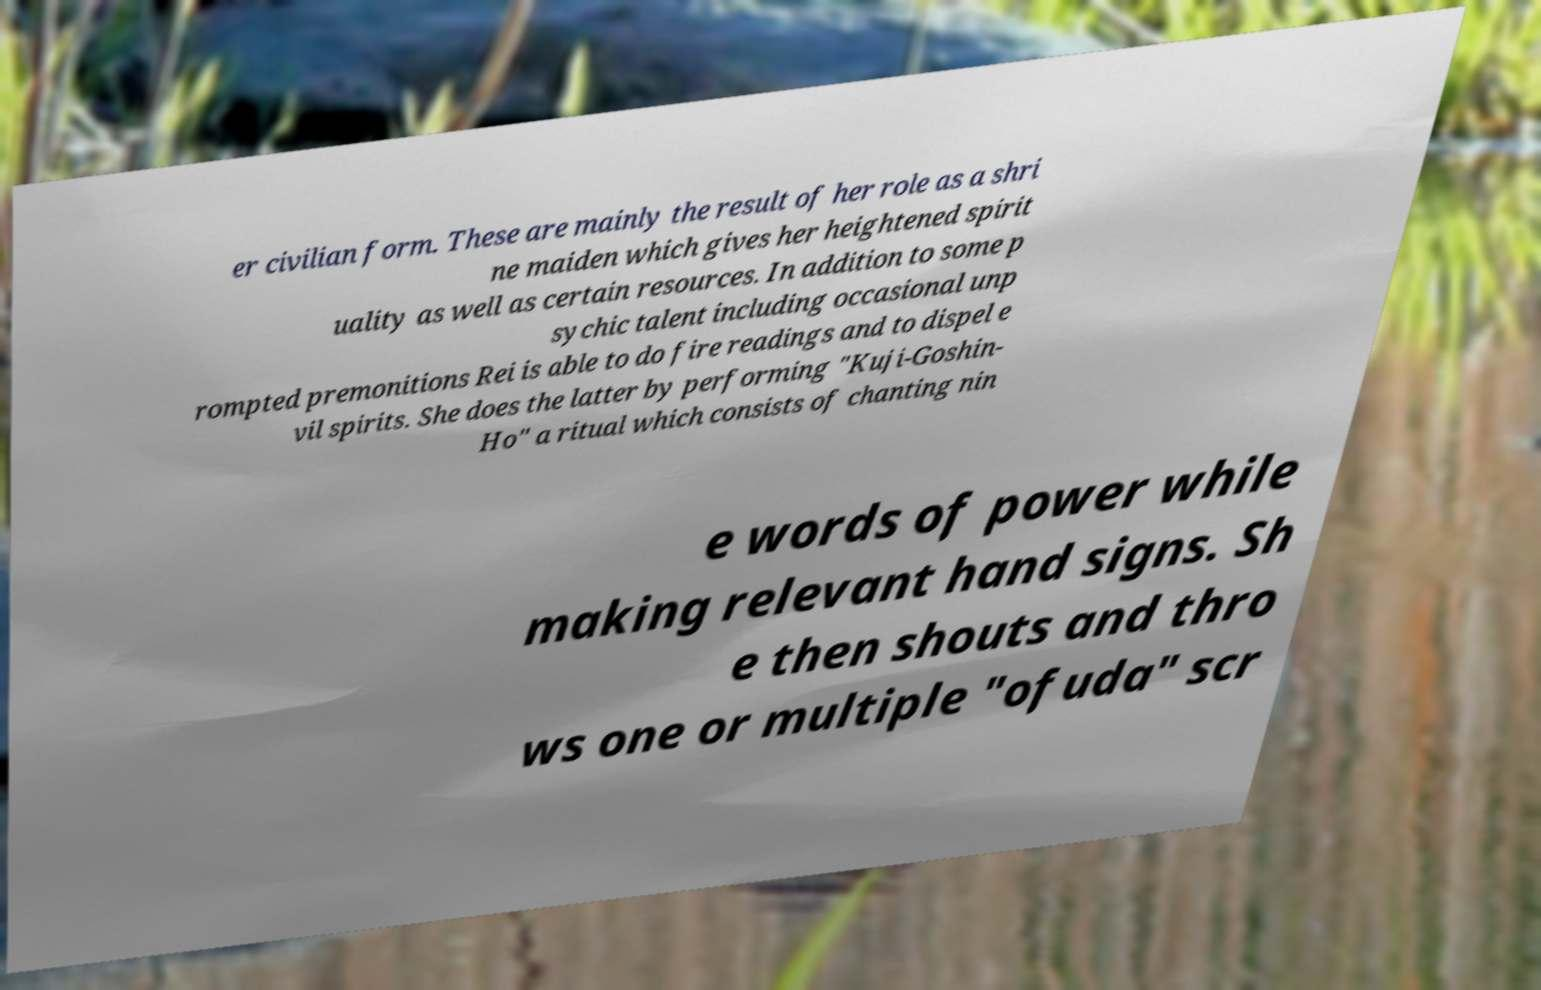I need the written content from this picture converted into text. Can you do that? er civilian form. These are mainly the result of her role as a shri ne maiden which gives her heightened spirit uality as well as certain resources. In addition to some p sychic talent including occasional unp rompted premonitions Rei is able to do fire readings and to dispel e vil spirits. She does the latter by performing "Kuji-Goshin- Ho" a ritual which consists of chanting nin e words of power while making relevant hand signs. Sh e then shouts and thro ws one or multiple "ofuda" scr 